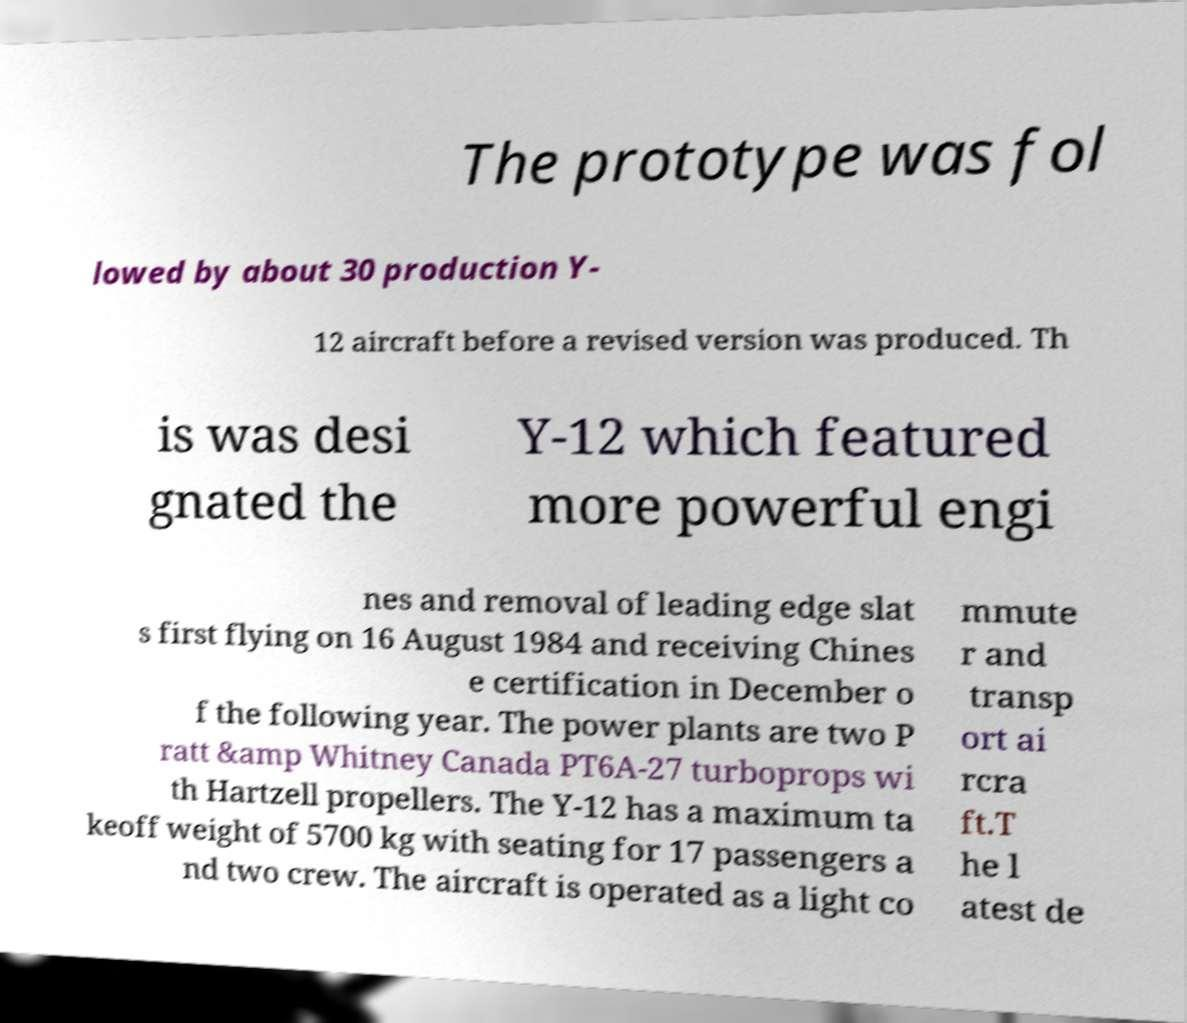Can you read and provide the text displayed in the image?This photo seems to have some interesting text. Can you extract and type it out for me? The prototype was fol lowed by about 30 production Y- 12 aircraft before a revised version was produced. Th is was desi gnated the Y-12 which featured more powerful engi nes and removal of leading edge slat s first flying on 16 August 1984 and receiving Chines e certification in December o f the following year. The power plants are two P ratt &amp Whitney Canada PT6A-27 turboprops wi th Hartzell propellers. The Y-12 has a maximum ta keoff weight of 5700 kg with seating for 17 passengers a nd two crew. The aircraft is operated as a light co mmute r and transp ort ai rcra ft.T he l atest de 